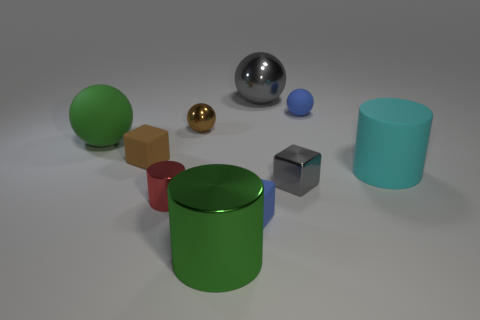Is the material of the gray thing left of the tiny gray block the same as the small brown cube?
Give a very brief answer. No. Are there the same number of green things that are in front of the big matte sphere and blue rubber blocks?
Offer a terse response. Yes. There is a large object that is behind the metallic sphere that is left of the small rubber block on the right side of the large green metal cylinder; what is it made of?
Make the answer very short. Metal. There is a thing that is the same color as the small metal block; what material is it?
Your answer should be very brief. Metal. What number of objects are large gray metallic objects that are right of the small shiny cylinder or cylinders?
Offer a terse response. 4. What number of objects are either small blue balls or metal things that are behind the green rubber sphere?
Your response must be concise. 3. What number of things are right of the rubber sphere behind the large green thing that is behind the large green shiny thing?
Provide a succinct answer. 1. There is a green cylinder that is the same size as the gray sphere; what material is it?
Offer a very short reply. Metal. Is there a brown rubber cube of the same size as the brown metal object?
Keep it short and to the point. Yes. What is the color of the large metallic ball?
Ensure brevity in your answer.  Gray. 